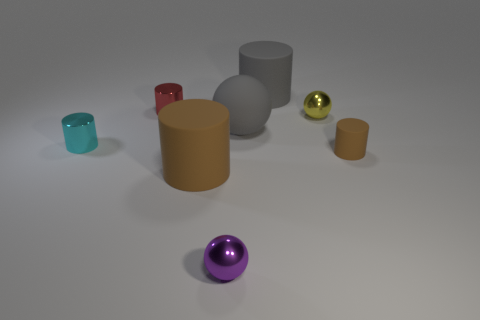Is the number of brown rubber objects less than the number of large gray cubes?
Your answer should be very brief. No. There is a tiny thing in front of the large brown object; is it the same color as the matte ball?
Provide a short and direct response. No. How many yellow cubes are the same size as the yellow shiny sphere?
Give a very brief answer. 0. Are there any big cylinders that have the same color as the matte sphere?
Your answer should be very brief. Yes. Is the cyan cylinder made of the same material as the gray cylinder?
Provide a succinct answer. No. What number of other cyan metallic objects are the same shape as the tiny cyan metallic object?
Give a very brief answer. 0. There is a tiny cyan thing that is the same material as the red object; what shape is it?
Give a very brief answer. Cylinder. There is a big cylinder that is behind the tiny metallic cylinder that is in front of the red metallic cylinder; what color is it?
Your answer should be very brief. Gray. Is the color of the large sphere the same as the tiny matte cylinder?
Your answer should be very brief. No. There is a tiny sphere that is left of the tiny metal ball that is behind the purple metal sphere; what is it made of?
Offer a terse response. Metal. 